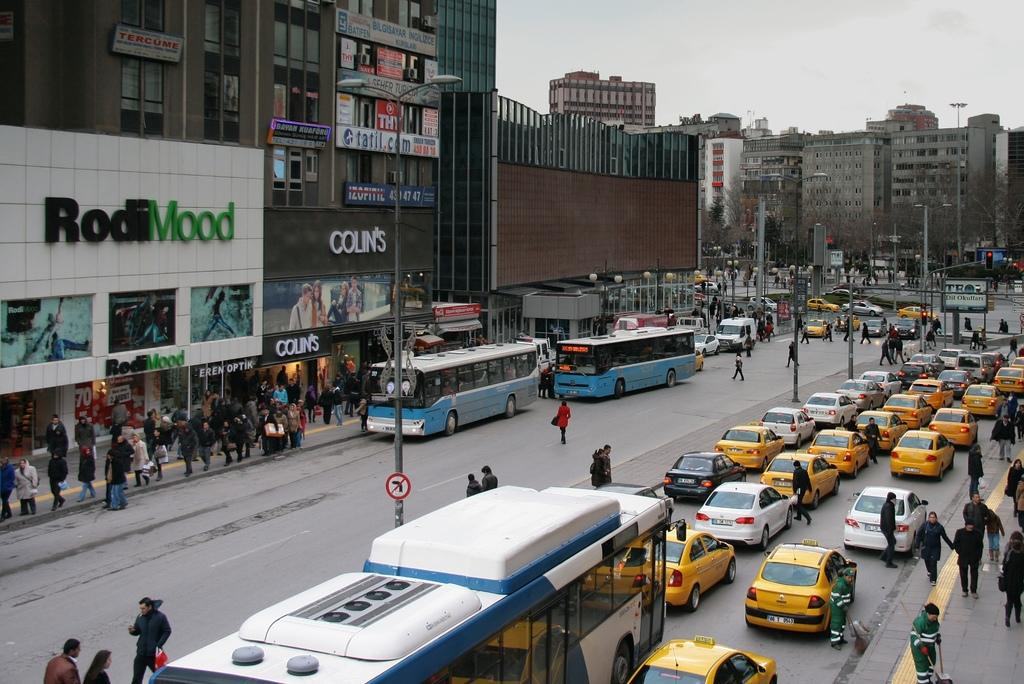<image>
Summarize the visual content of the image. Heavy traffic outside of stores Colin's and Rodi Mood. 